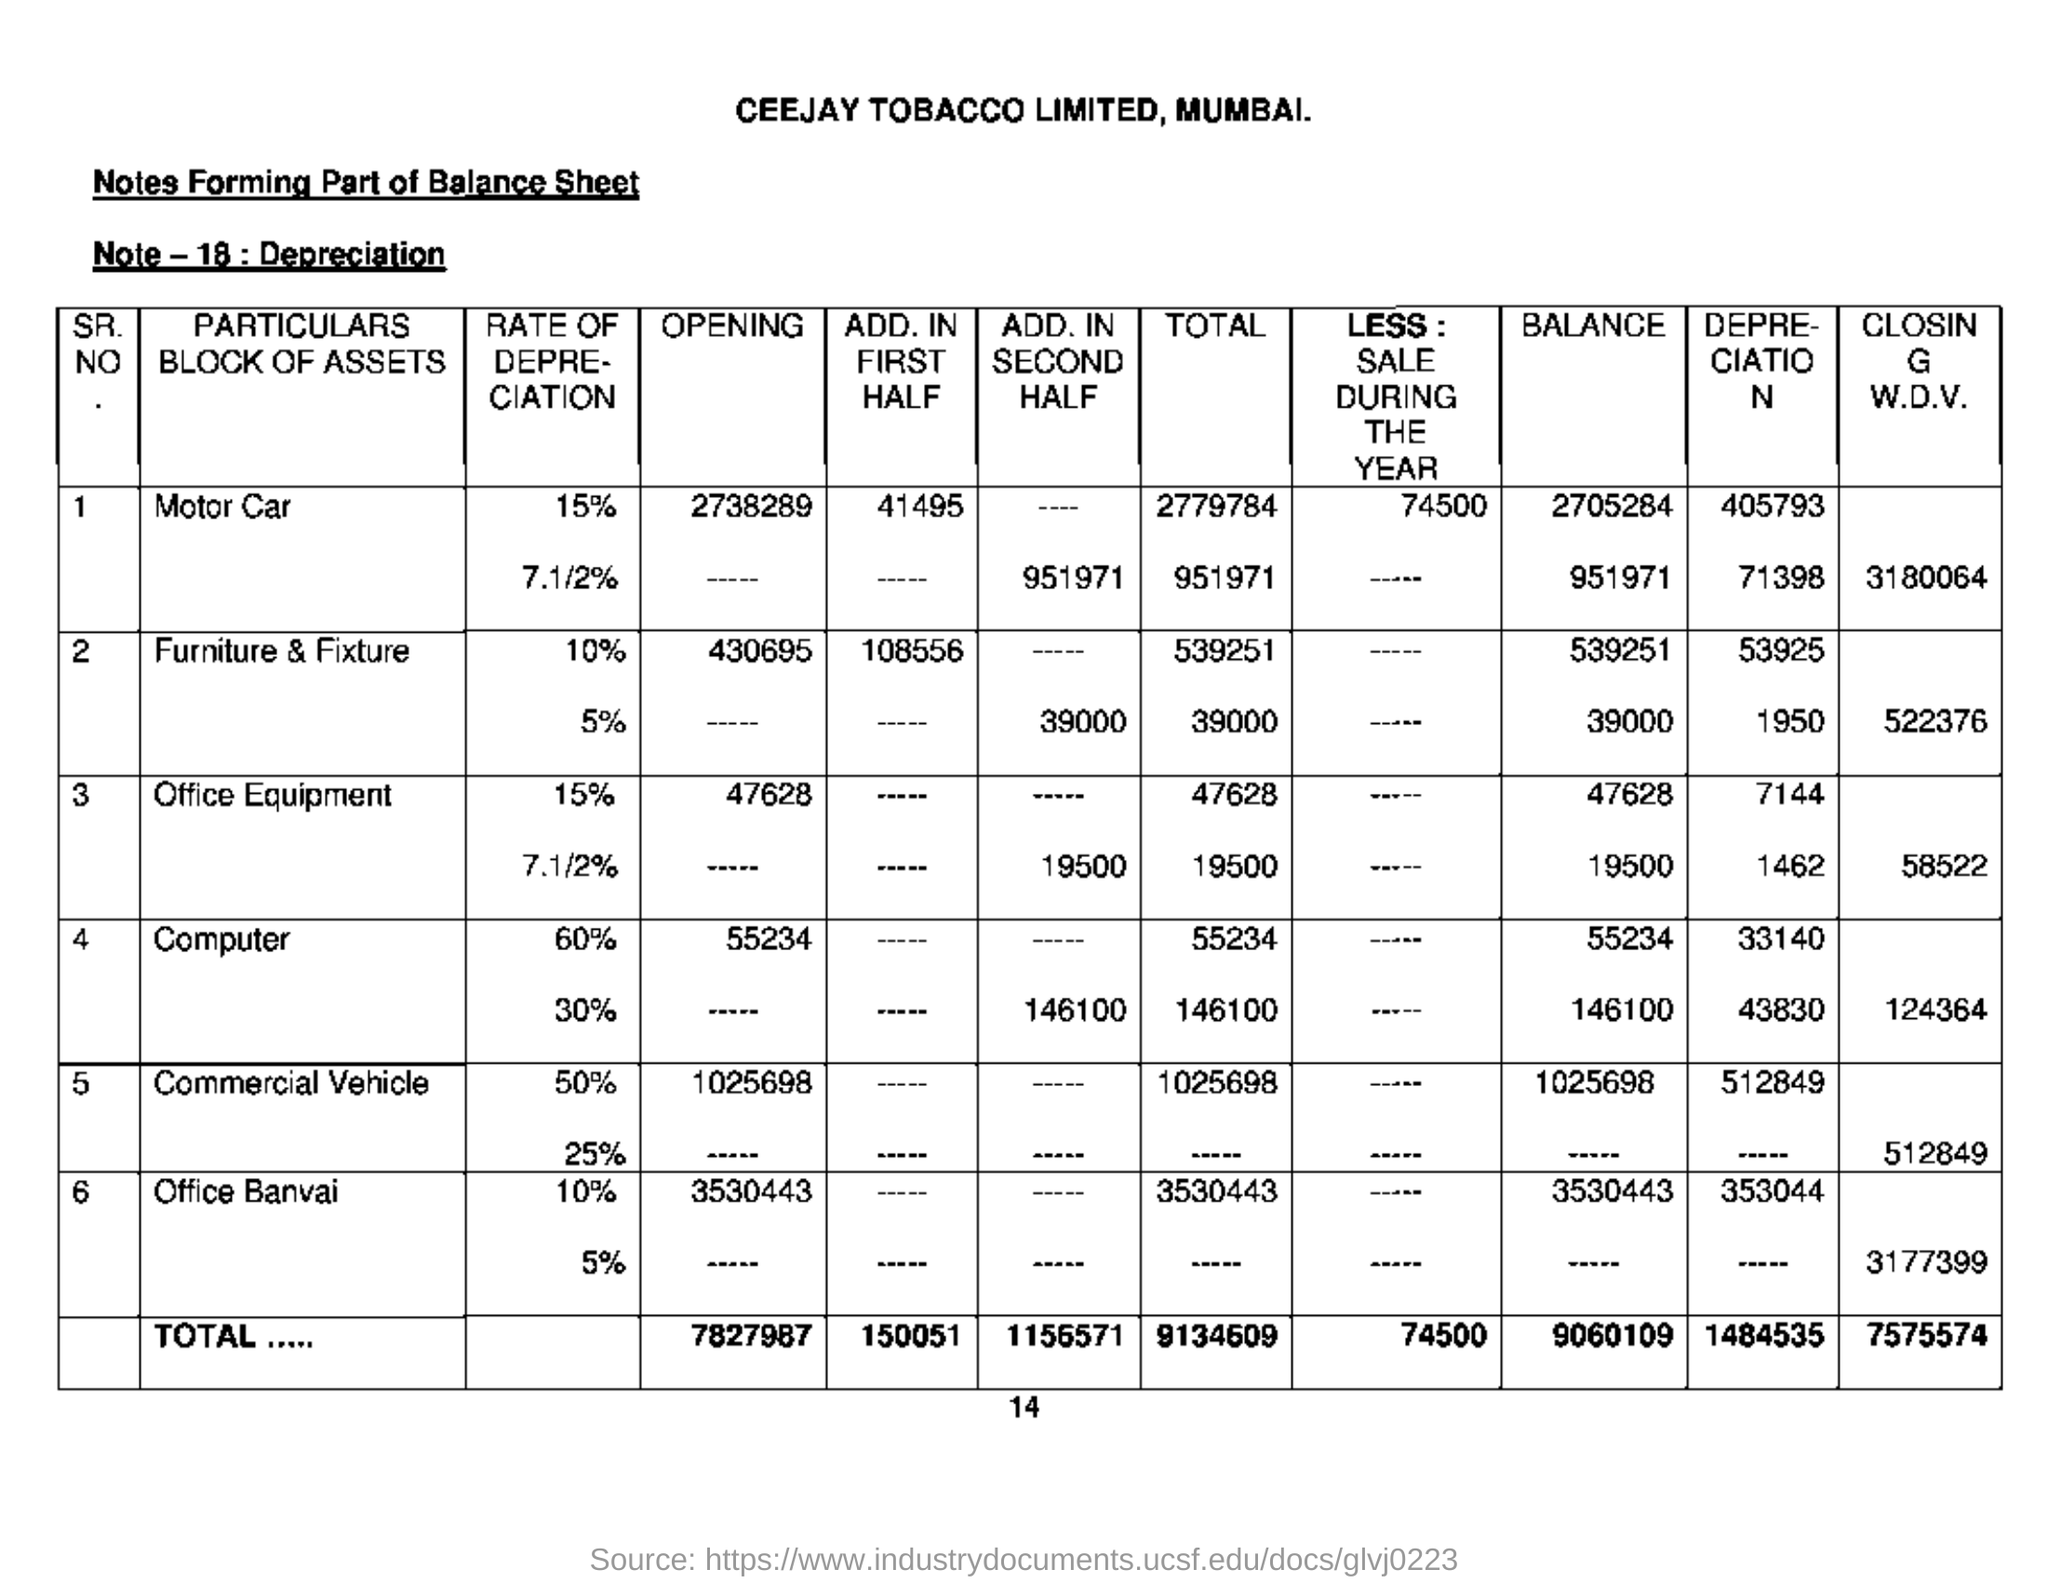Which companies balance sheet is this?
Offer a terse response. Ceejay Tobacco Limited, Mumbai. What does Note-18 says about ?
Offer a terse response. Depreciation. 